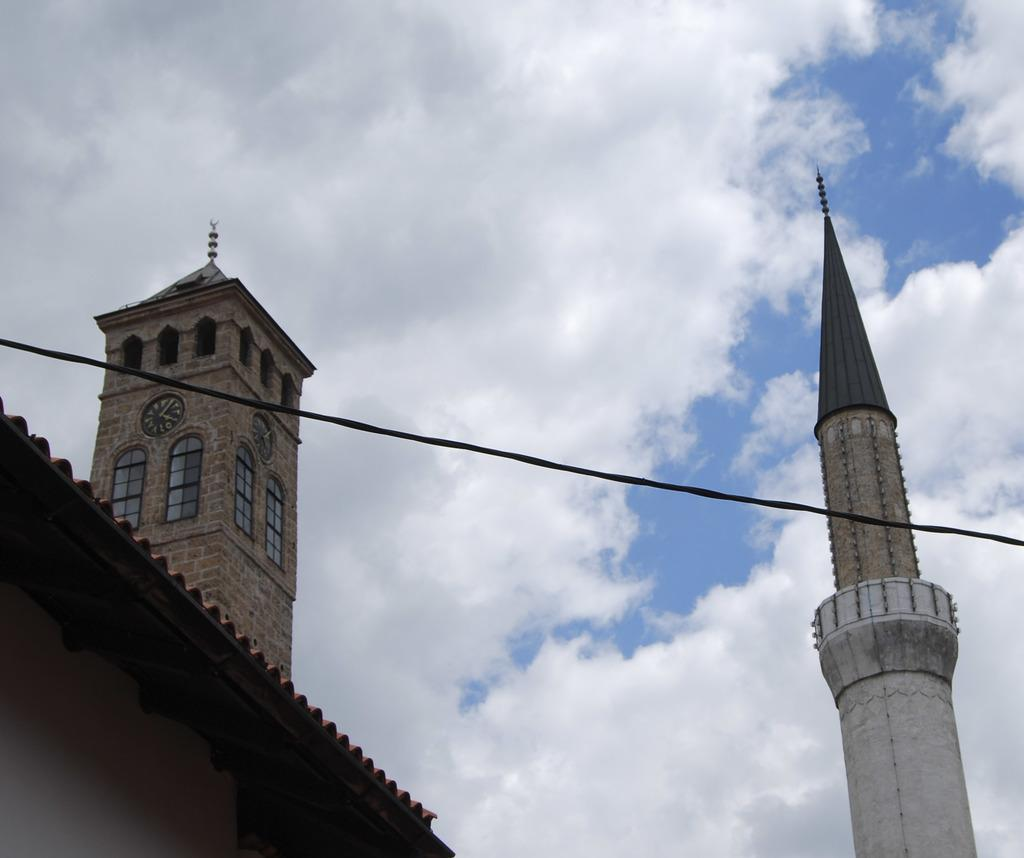What is the main object in the center of the image? There is a rope in the center of the image. What type of structure can be seen in the image? There is a building with a clock tower in the image. What can be seen in the sky in the image? There are clouds visible at the top of the image. How many thumbs are visible in the image? There are no thumbs visible in the image. What type of bird is part of the flock flying in the image? There are no birds or flocks present in the image. 